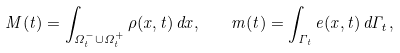<formula> <loc_0><loc_0><loc_500><loc_500>M ( t ) = \int _ { \Omega ^ { - } _ { t } \cup \Omega ^ { + } _ { t } } \rho ( x , t ) \, d x , \quad m ( t ) = \int _ { \Gamma _ { t } } e ( x , t ) \, d \Gamma _ { t } ,</formula> 